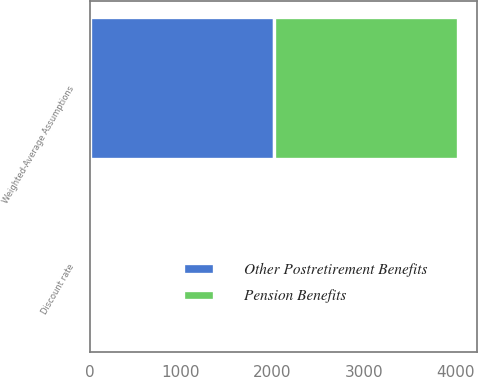<chart> <loc_0><loc_0><loc_500><loc_500><stacked_bar_chart><ecel><fcel>Weighted-Average Assumptions<fcel>Discount rate<nl><fcel>Pension Benefits<fcel>2017<fcel>3.71<nl><fcel>Other Postretirement Benefits<fcel>2017<fcel>3.71<nl></chart> 